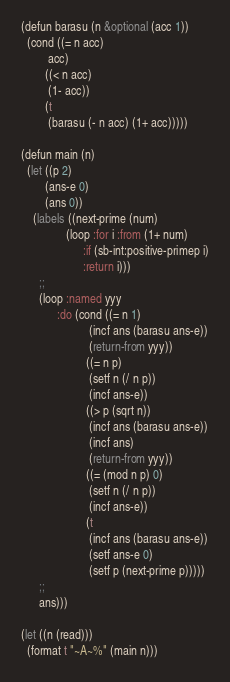Convert code to text. <code><loc_0><loc_0><loc_500><loc_500><_Lisp_>(defun barasu (n &optional (acc 1))
  (cond ((= n acc)
         acc)
        ((< n acc)
         (1- acc))
        (t 
         (barasu (- n acc) (1+ acc)))))      

(defun main (n)
  (let ((p 2)
        (ans-e 0)
        (ans 0))
    (labels ((next-prime (num)
               (loop :for i :from (1+ num)
                     :if (sb-int:positive-primep i)
                     :return i)))
      ;;
      (loop :named yyy
            :do (cond ((= n 1)
                       (incf ans (barasu ans-e))
                       (return-from yyy))
                      ((= n p)
                       (setf n (/ n p))
                       (incf ans-e))
                      ((> p (sqrt n))
                       (incf ans (barasu ans-e))
                       (incf ans)
                       (return-from yyy))
                      ((= (mod n p) 0)
                       (setf n (/ n p))
                       (incf ans-e))
                      (t
                       (incf ans (barasu ans-e))
                       (setf ans-e 0)
                       (setf p (next-prime p)))))
      ;;
      ans)))

(let ((n (read)))
  (format t "~A~%" (main n)))
</code> 